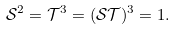<formula> <loc_0><loc_0><loc_500><loc_500>\mathcal { S } ^ { 2 } = \mathcal { T } ^ { 3 } = ( \mathcal { S } \mathcal { T } ) ^ { 3 } = 1 .</formula> 